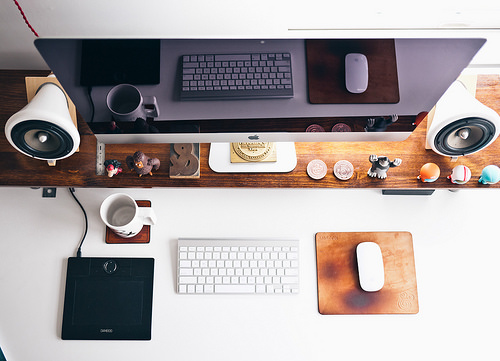<image>
Can you confirm if the speaker is above the toy helmet? Yes. The speaker is positioned above the toy helmet in the vertical space, higher up in the scene. 